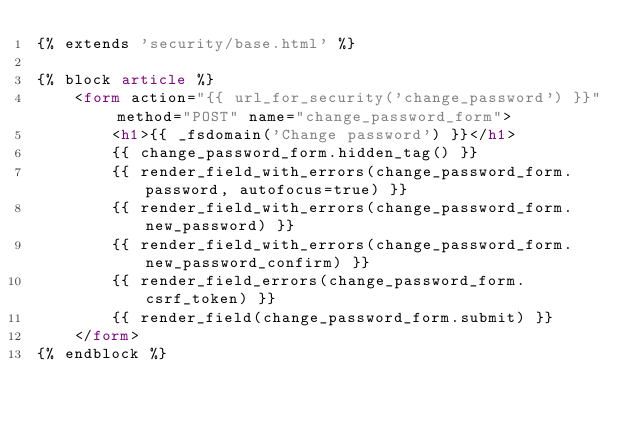Convert code to text. <code><loc_0><loc_0><loc_500><loc_500><_HTML_>{% extends 'security/base.html' %}

{% block article %}
    <form action="{{ url_for_security('change_password') }}" method="POST" name="change_password_form">
        <h1>{{ _fsdomain('Change password') }}</h1>
        {{ change_password_form.hidden_tag() }}
        {{ render_field_with_errors(change_password_form.password, autofocus=true) }}
        {{ render_field_with_errors(change_password_form.new_password) }}
        {{ render_field_with_errors(change_password_form.new_password_confirm) }}
        {{ render_field_errors(change_password_form.csrf_token) }}
        {{ render_field(change_password_form.submit) }}
    </form>
{% endblock %}
</code> 